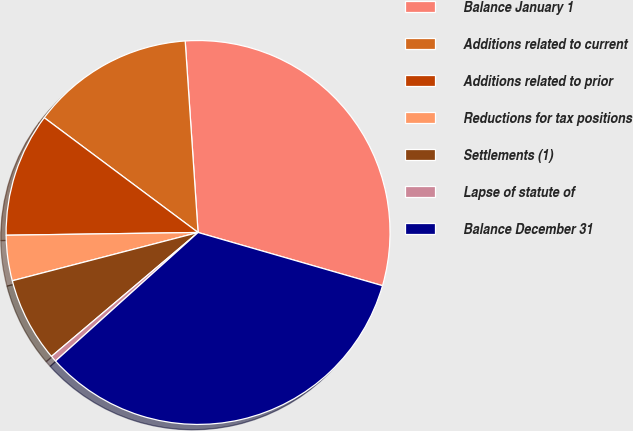Convert chart. <chart><loc_0><loc_0><loc_500><loc_500><pie_chart><fcel>Balance January 1<fcel>Additions related to current<fcel>Additions related to prior<fcel>Reductions for tax positions<fcel>Settlements (1)<fcel>Lapse of statute of<fcel>Balance December 31<nl><fcel>30.54%<fcel>13.73%<fcel>10.43%<fcel>3.82%<fcel>7.12%<fcel>0.51%<fcel>33.85%<nl></chart> 